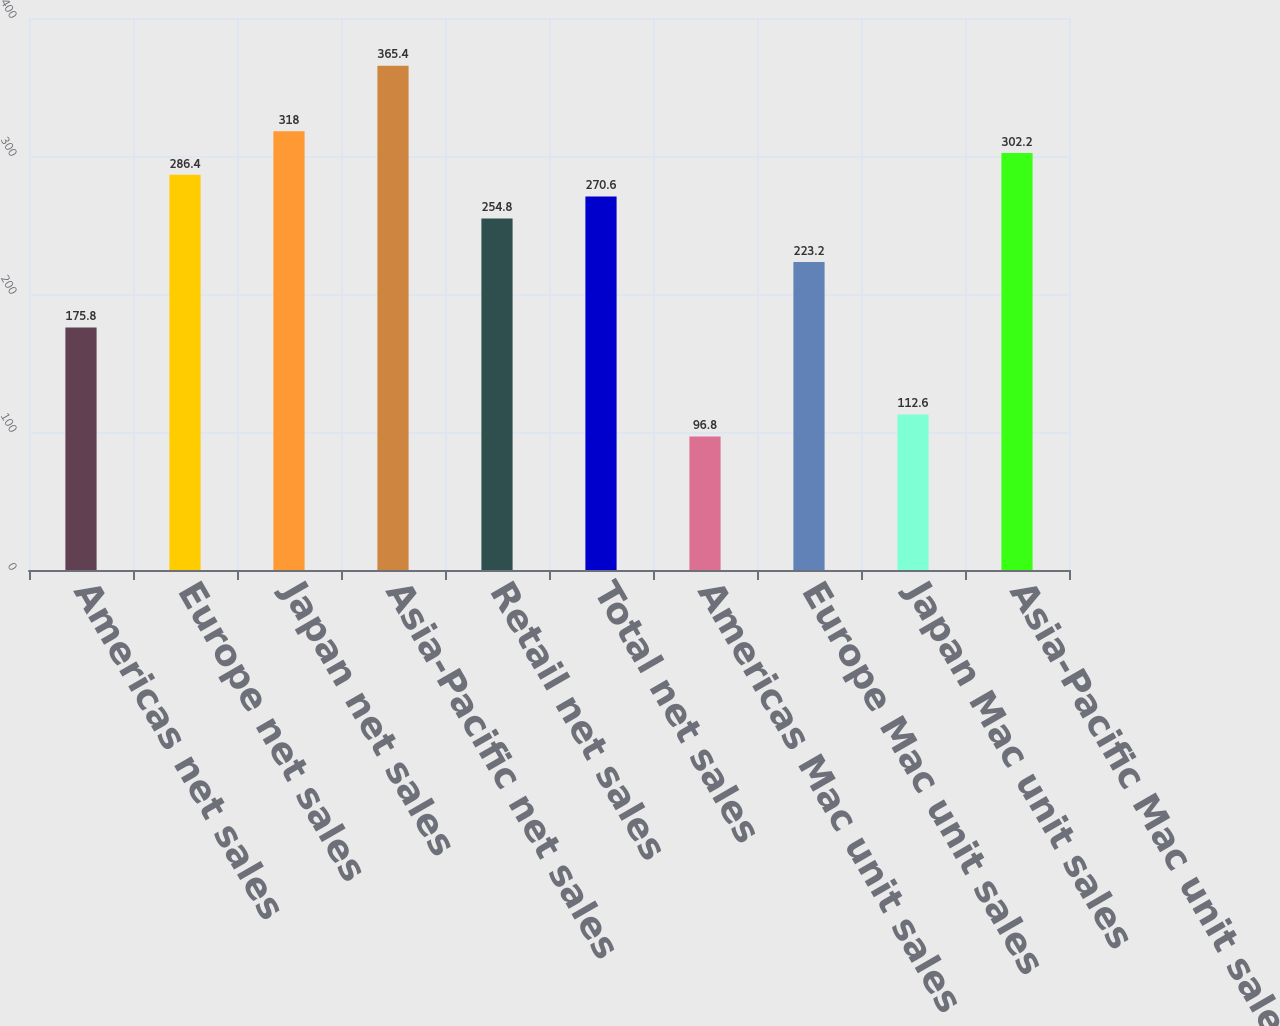<chart> <loc_0><loc_0><loc_500><loc_500><bar_chart><fcel>Americas net sales<fcel>Europe net sales<fcel>Japan net sales<fcel>Asia-Pacific net sales<fcel>Retail net sales<fcel>Total net sales<fcel>Americas Mac unit sales<fcel>Europe Mac unit sales<fcel>Japan Mac unit sales<fcel>Asia-Pacific Mac unit sales<nl><fcel>175.8<fcel>286.4<fcel>318<fcel>365.4<fcel>254.8<fcel>270.6<fcel>96.8<fcel>223.2<fcel>112.6<fcel>302.2<nl></chart> 